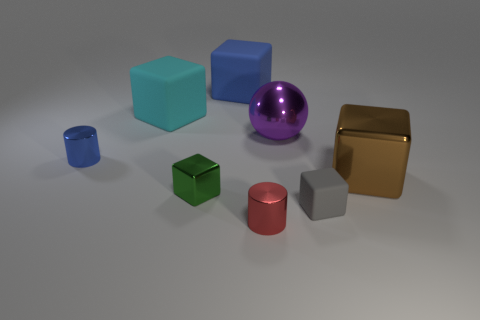Subtract 1 blocks. How many blocks are left? 4 Subtract all blue blocks. How many blocks are left? 4 Subtract all purple blocks. Subtract all cyan spheres. How many blocks are left? 5 Add 1 matte things. How many objects exist? 9 Subtract all cubes. How many objects are left? 3 Add 5 green cubes. How many green cubes are left? 6 Add 1 blue rubber cylinders. How many blue rubber cylinders exist? 1 Subtract 1 cyan cubes. How many objects are left? 7 Subtract all big cyan things. Subtract all large balls. How many objects are left? 6 